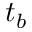<formula> <loc_0><loc_0><loc_500><loc_500>t _ { b }</formula> 